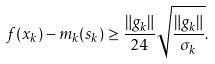Convert formula to latex. <formula><loc_0><loc_0><loc_500><loc_500>f ( x _ { k } ) - m _ { k } ( s _ { k } ) \geq \frac { \| g _ { k } \| } { 2 4 } \sqrt { \frac { \| g _ { k } \| } { \sigma _ { k } } } .</formula> 